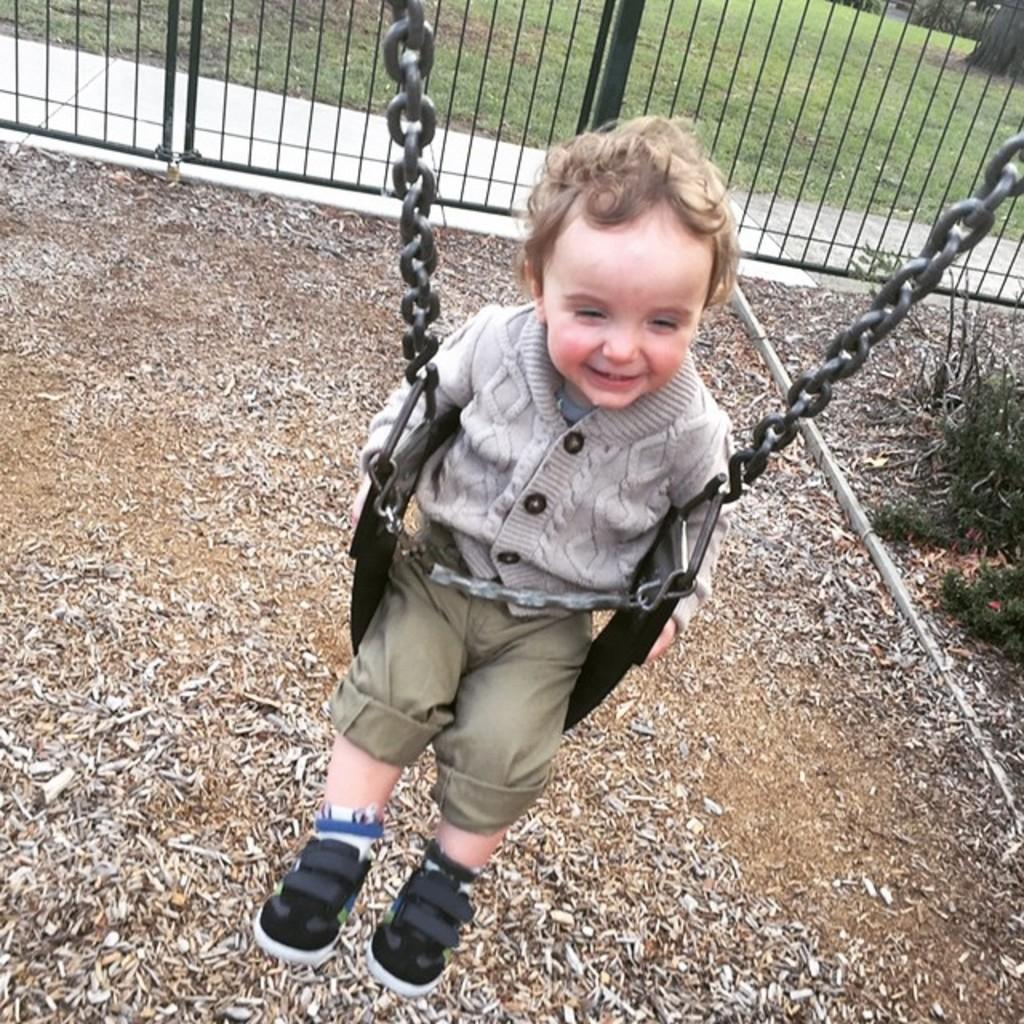Who is present in the image? There is a boy in the image. What is the boy doing in the image? The boy is sitting on a swing. What type of vegetation can be seen in the image? There are plants and grass in the image. What architectural feature is visible in the image? There is a fence in the image. Where is the cave located in the image? There is no cave present in the image. What time does the boy's watch show in the image? There is no watch visible in the image. 